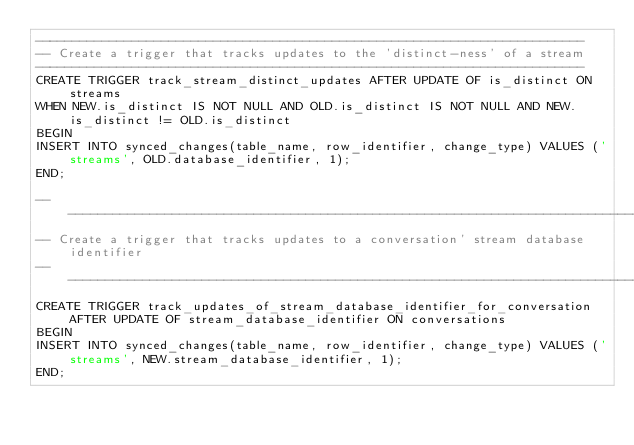<code> <loc_0><loc_0><loc_500><loc_500><_SQL_>--------------------------------------------------------------------------
-- Create a trigger that tracks updates to the 'distinct-ness' of a stream
--------------------------------------------------------------------------
CREATE TRIGGER track_stream_distinct_updates AFTER UPDATE OF is_distinct ON streams
WHEN NEW.is_distinct IS NOT NULL AND OLD.is_distinct IS NOT NULL AND NEW.is_distinct != OLD.is_distinct
BEGIN
INSERT INTO synced_changes(table_name, row_identifier, change_type) VALUES ('streams', OLD.database_identifier, 1);
END;

-------------------------------------------------------------------------------------
-- Create a trigger that tracks updates to a conversation' stream database identifier
-------------------------------------------------------------------------------------
CREATE TRIGGER track_updates_of_stream_database_identifier_for_conversation AFTER UPDATE OF stream_database_identifier ON conversations
BEGIN
INSERT INTO synced_changes(table_name, row_identifier, change_type) VALUES ('streams', NEW.stream_database_identifier, 1);
END;
</code> 